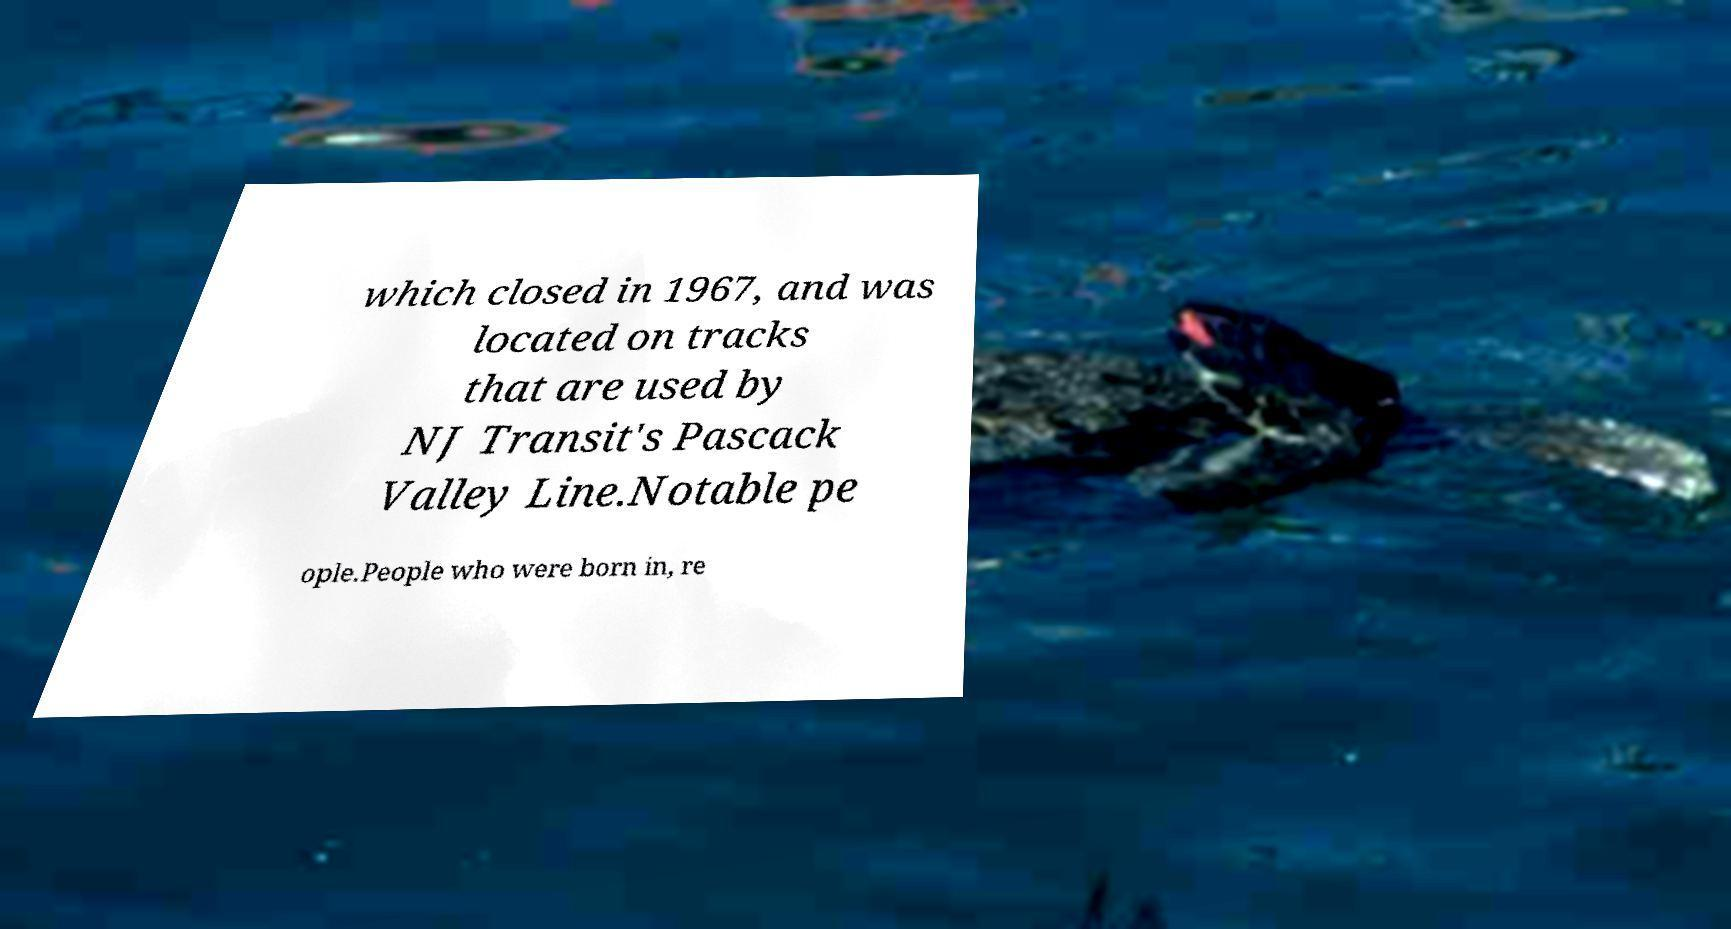Could you assist in decoding the text presented in this image and type it out clearly? which closed in 1967, and was located on tracks that are used by NJ Transit's Pascack Valley Line.Notable pe ople.People who were born in, re 